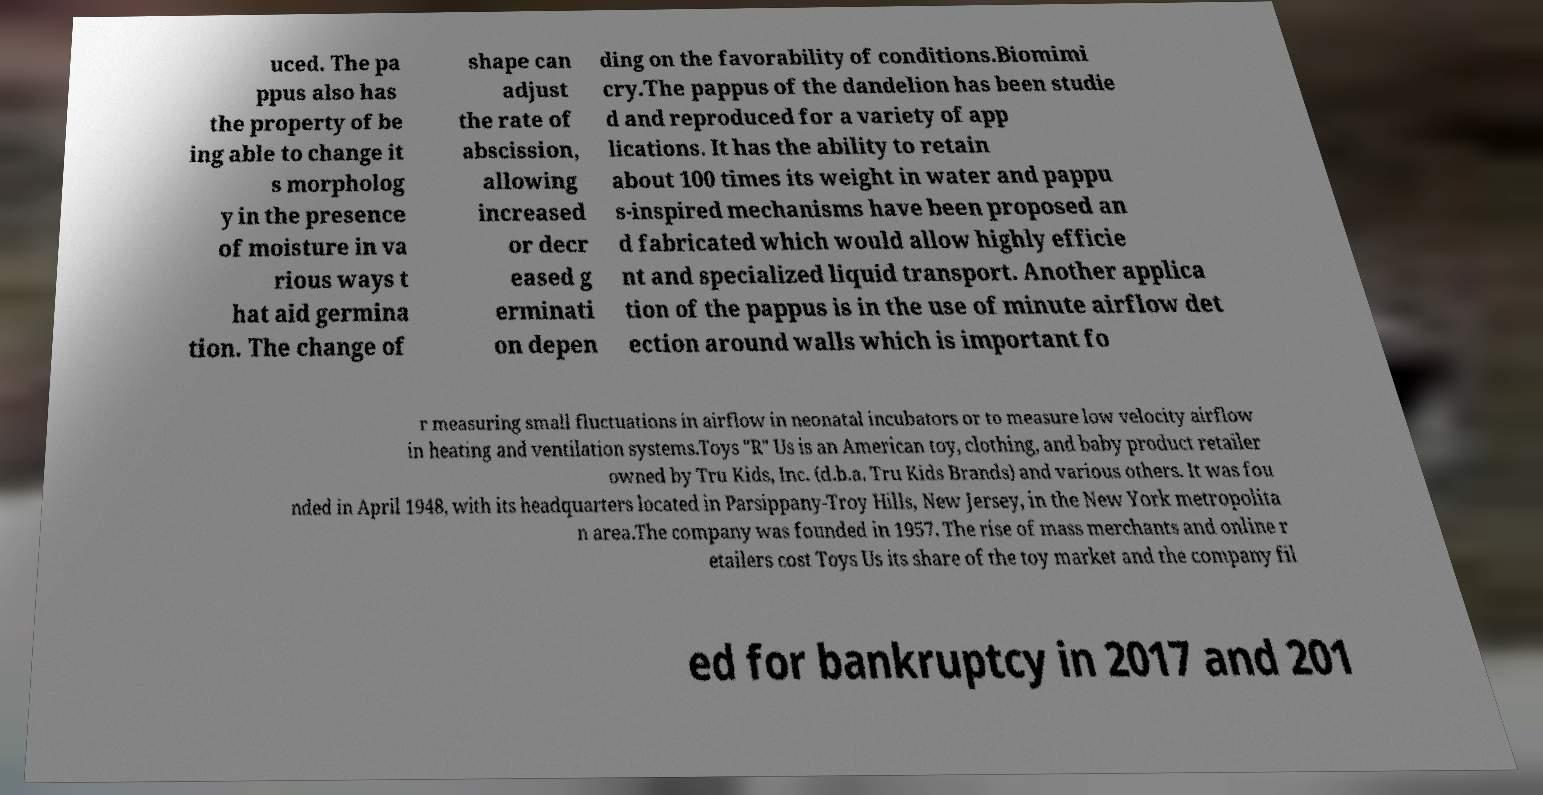Could you assist in decoding the text presented in this image and type it out clearly? uced. The pa ppus also has the property of be ing able to change it s morpholog y in the presence of moisture in va rious ways t hat aid germina tion. The change of shape can adjust the rate of abscission, allowing increased or decr eased g erminati on depen ding on the favorability of conditions.Biomimi cry.The pappus of the dandelion has been studie d and reproduced for a variety of app lications. It has the ability to retain about 100 times its weight in water and pappu s-inspired mechanisms have been proposed an d fabricated which would allow highly efficie nt and specialized liquid transport. Another applica tion of the pappus is in the use of minute airflow det ection around walls which is important fo r measuring small fluctuations in airflow in neonatal incubators or to measure low velocity airflow in heating and ventilation systems.Toys "R" Us is an American toy, clothing, and baby product retailer owned by Tru Kids, Inc. (d.b.a. Tru Kids Brands) and various others. It was fou nded in April 1948, with its headquarters located in Parsippany-Troy Hills, New Jersey, in the New York metropolita n area.The company was founded in 1957. The rise of mass merchants and online r etailers cost Toys Us its share of the toy market and the company fil ed for bankruptcy in 2017 and 201 